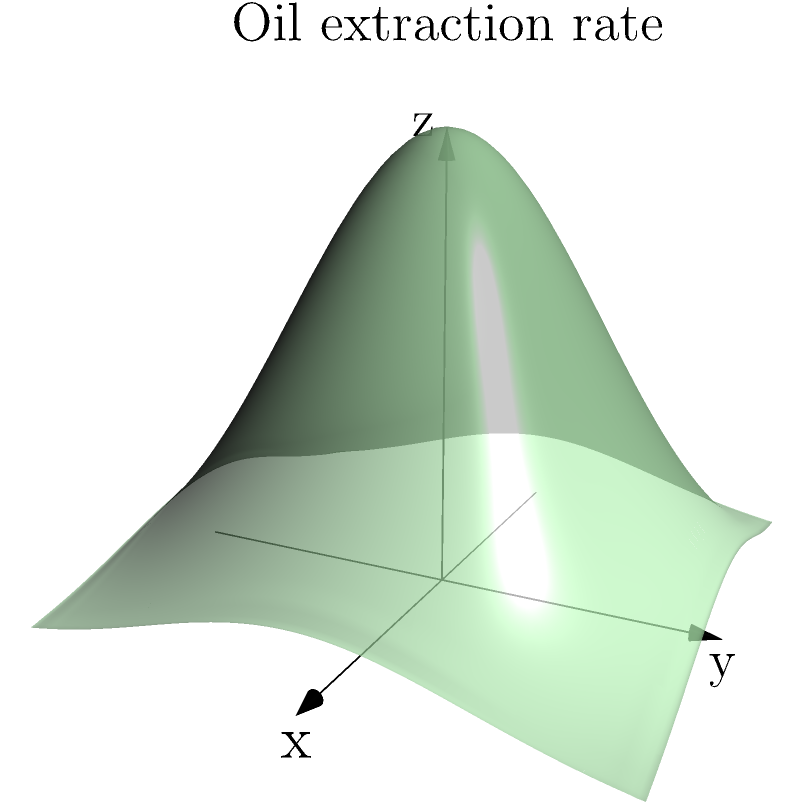An oil company is extracting oil from an Arctic reserve. The rate of oil extraction (in barrels per day) at a location $(x,y)$ (in kilometers from the center of the reserve) is modeled by the function:

$$f(x,y) = 500e^{-0.2(x^2+y^2)}$$

Calculate the total volume of oil (in barrels) extracted from the entire reserve over a 30-day period. To solve this problem, we need to follow these steps:

1) The total volume of oil extracted is the triple integral of the function over the entire xy-plane for 30 days:

   $$V = 30 \int_{-\infty}^{\infty} \int_{-\infty}^{\infty} f(x,y) \, dy \, dx$$

2) Substituting the given function:

   $$V = 30 \int_{-\infty}^{\infty} \int_{-\infty}^{\infty} 500e^{-0.2(x^2+y^2)} \, dy \, dx$$

3) Due to the symmetry of the function, we can use polar coordinates. The transformation is:
   $x = r\cos(\theta)$, $y = r\sin(\theta)$, and $dx\,dy = r\,dr\,d\theta$

4) The integral becomes:

   $$V = 30 \cdot 500 \int_{0}^{2\pi} \int_{0}^{\infty} e^{-0.2r^2} r \, dr \, d\theta$$

5) Evaluating the inner integral:

   $$\int_{0}^{\infty} e^{-0.2r^2} r \, dr = -\frac{1}{0.4} e^{-0.2r^2} \bigg|_{0}^{\infty} = \frac{1}{0.4} = 2.5$$

6) The integral simplifies to:

   $$V = 30 \cdot 500 \cdot 2.5 \int_{0}^{2\pi} d\theta = 30 \cdot 500 \cdot 2.5 \cdot 2\pi$$

7) Calculate the final result:

   $$V = 30 \cdot 500 \cdot 2.5 \cdot 2\pi = 235,619.45$$

Thus, the total volume of oil extracted over 30 days is approximately 235,619 barrels.
Answer: 235,619 barrels 